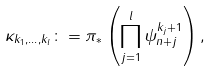Convert formula to latex. <formula><loc_0><loc_0><loc_500><loc_500>\kappa _ { k _ { 1 } , \dots , k _ { l } } \colon = \pi _ { * } \left ( \prod _ { j = 1 } ^ { l } \psi _ { n + j } ^ { k _ { j } + 1 } \right ) ,</formula> 